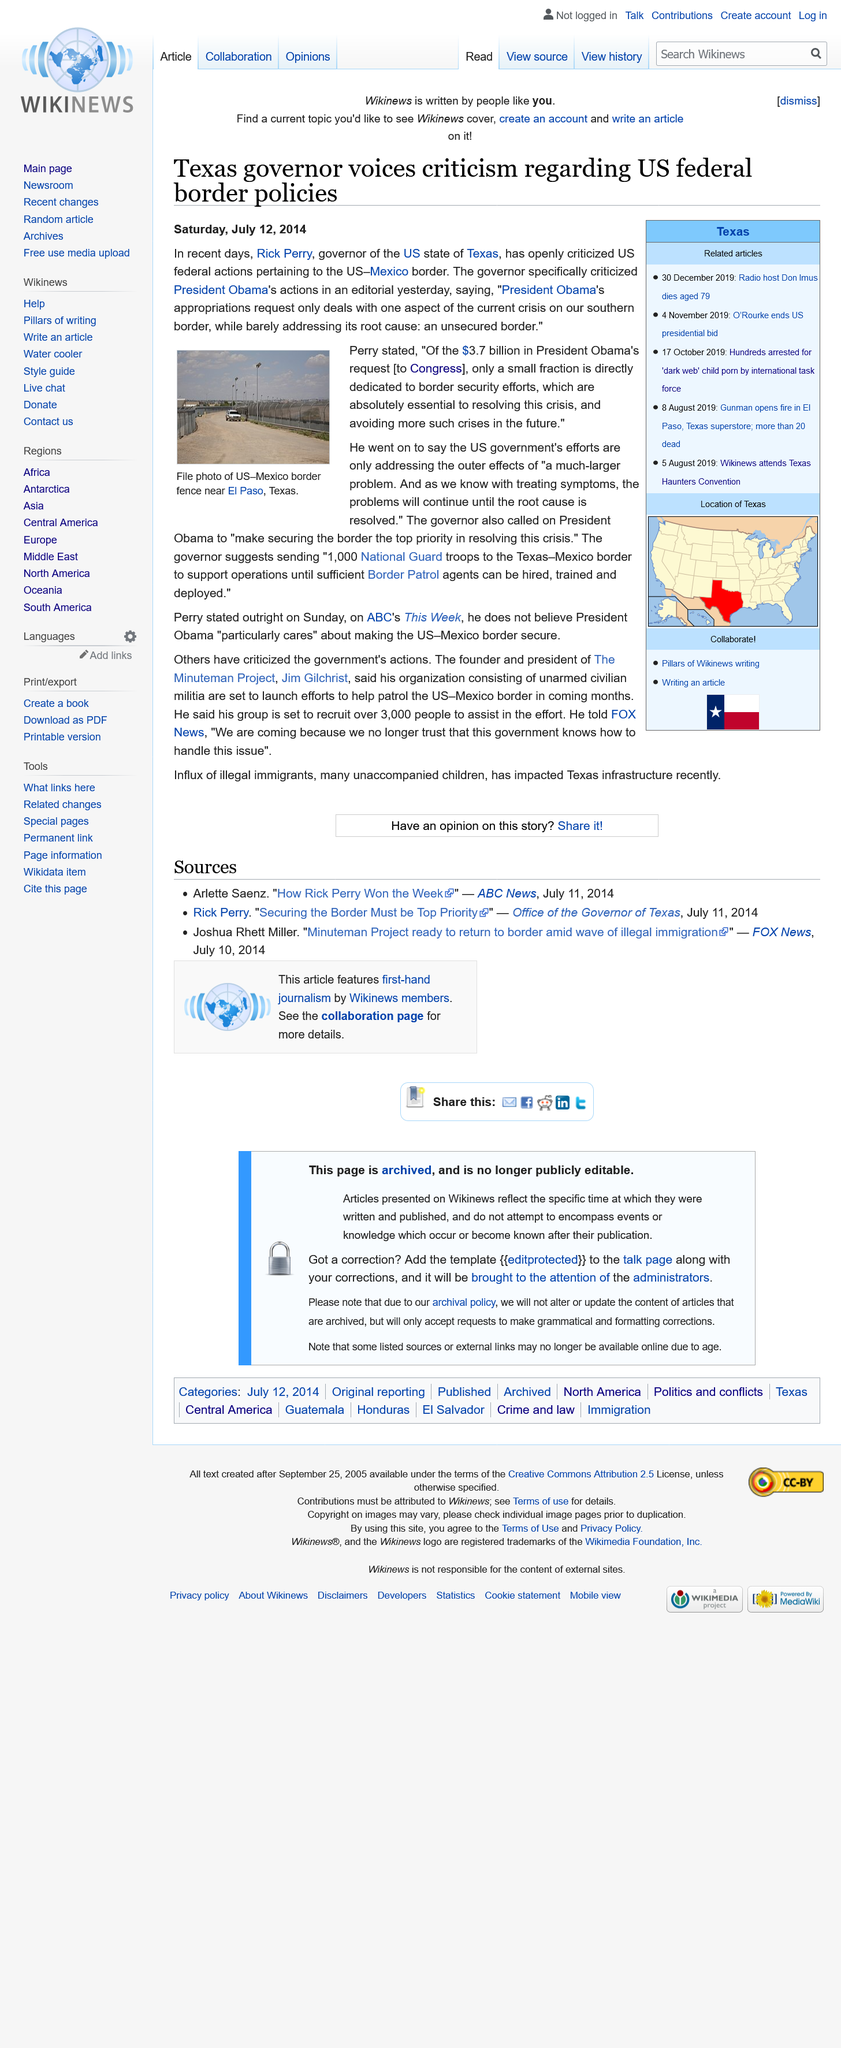Specify some key components in this picture. The article was published on Saturday, July 12, 2014, as declared in the sentence. The article was published on Saturday, July 12, 2014, and the governor of Texas at that time was Rick Perry. Don Imus, a radio host, died at the age of 79. Don Imus was 79 years old when he died. 